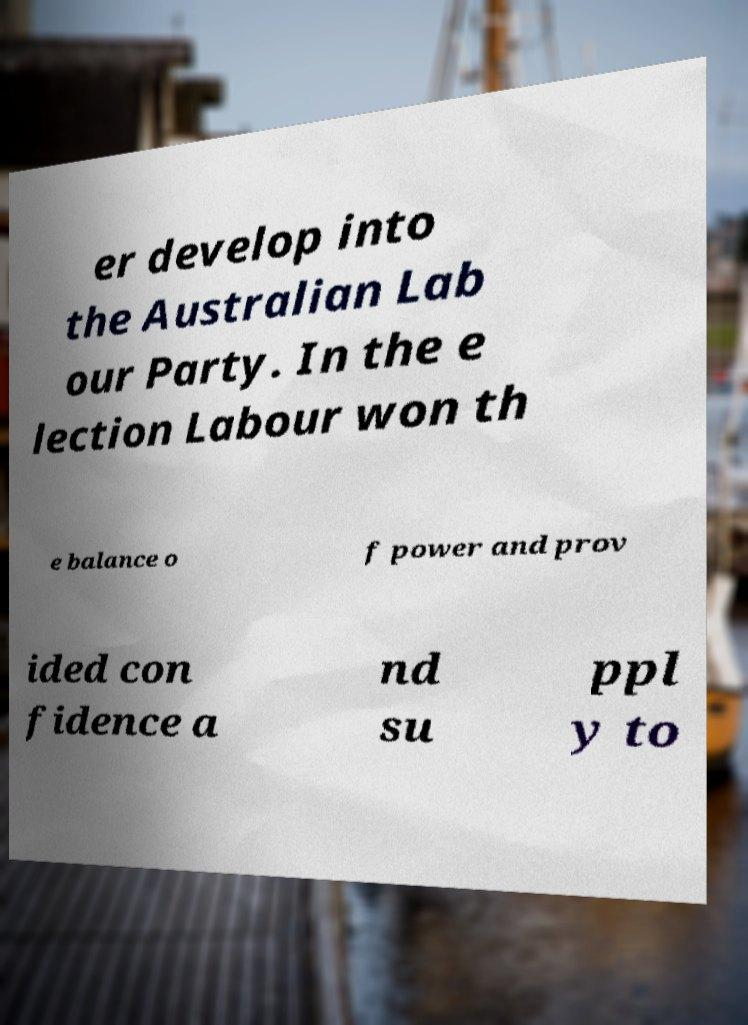Can you accurately transcribe the text from the provided image for me? er develop into the Australian Lab our Party. In the e lection Labour won th e balance o f power and prov ided con fidence a nd su ppl y to 